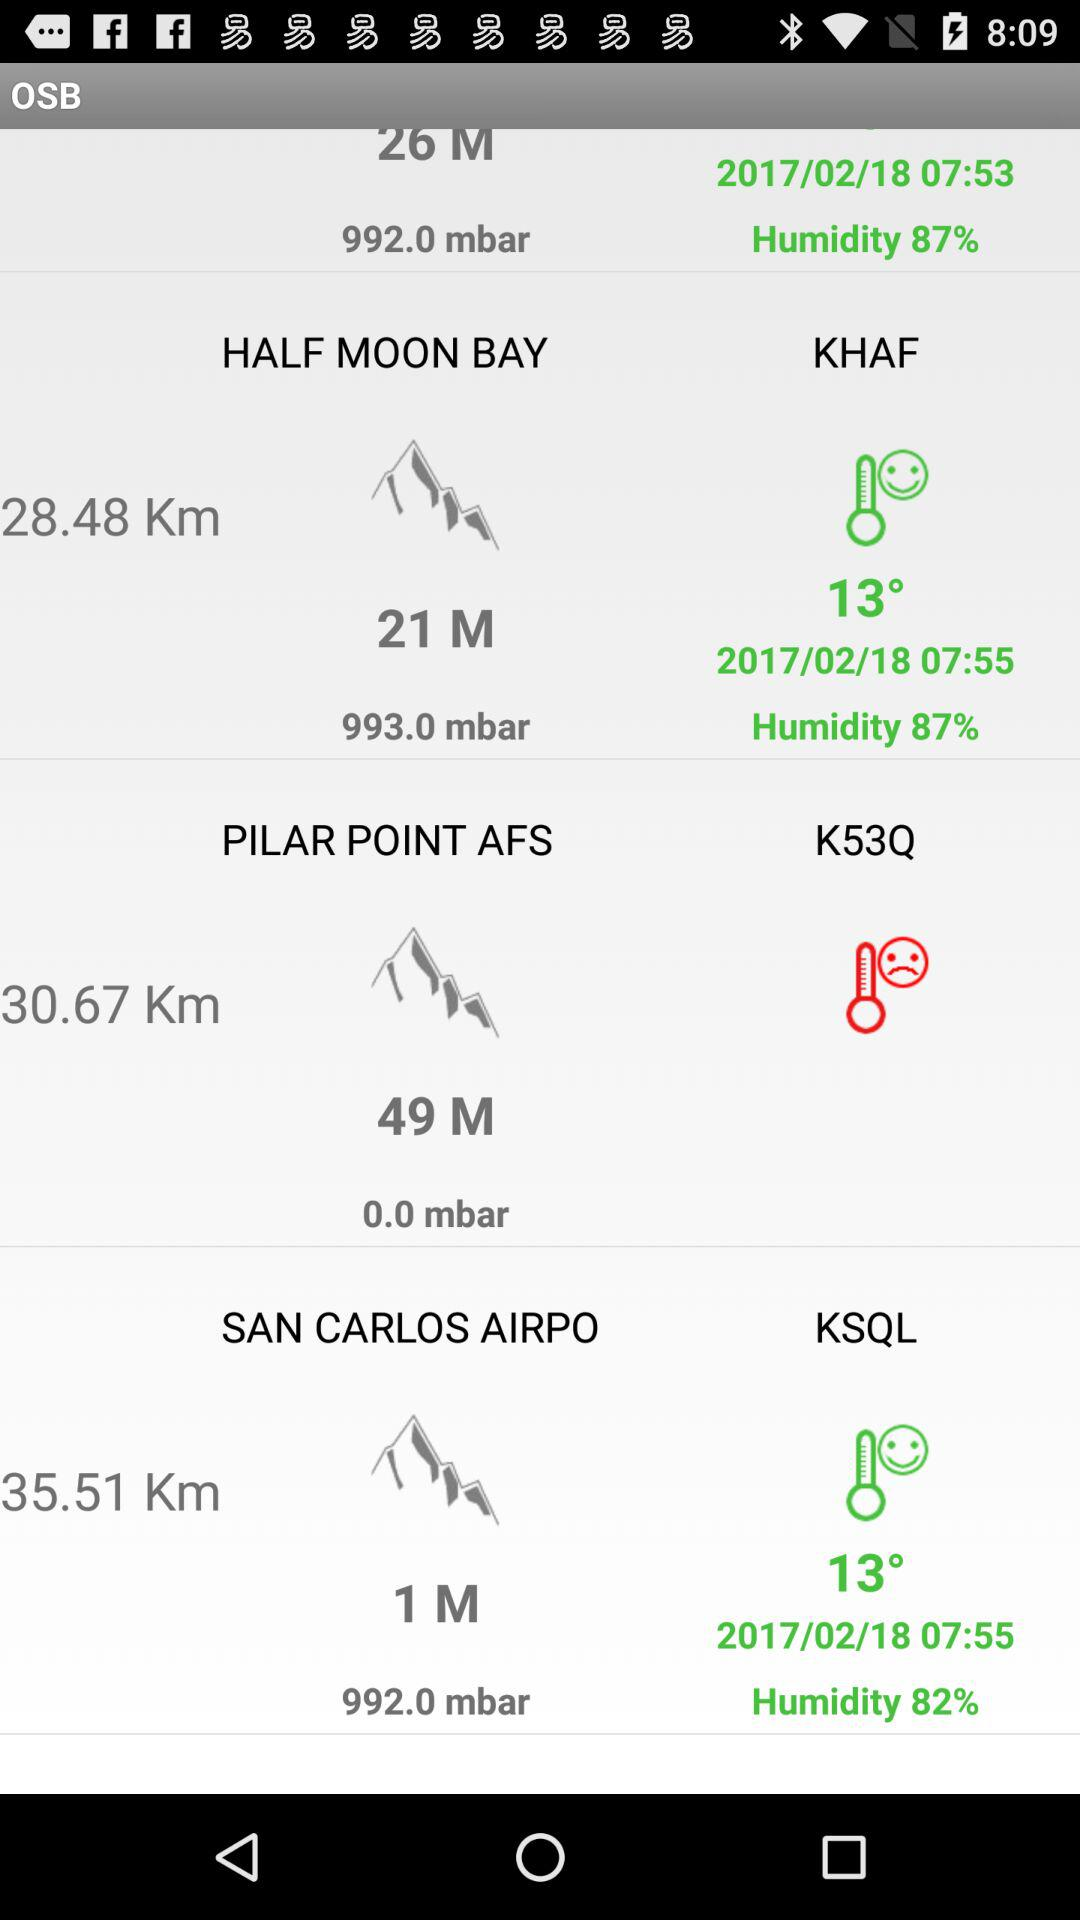What is the distance to Half Moon Bay? The distance to Half Moon Bay is 24.48 km. 